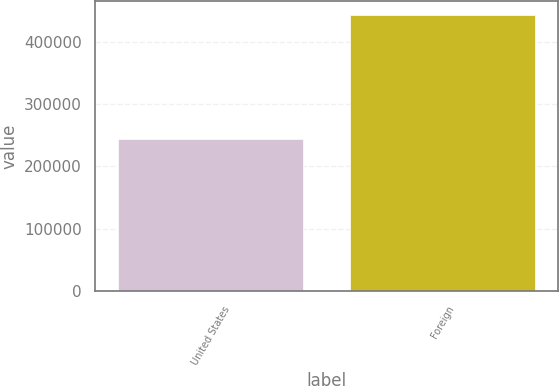<chart> <loc_0><loc_0><loc_500><loc_500><bar_chart><fcel>United States<fcel>Foreign<nl><fcel>243754<fcel>443102<nl></chart> 